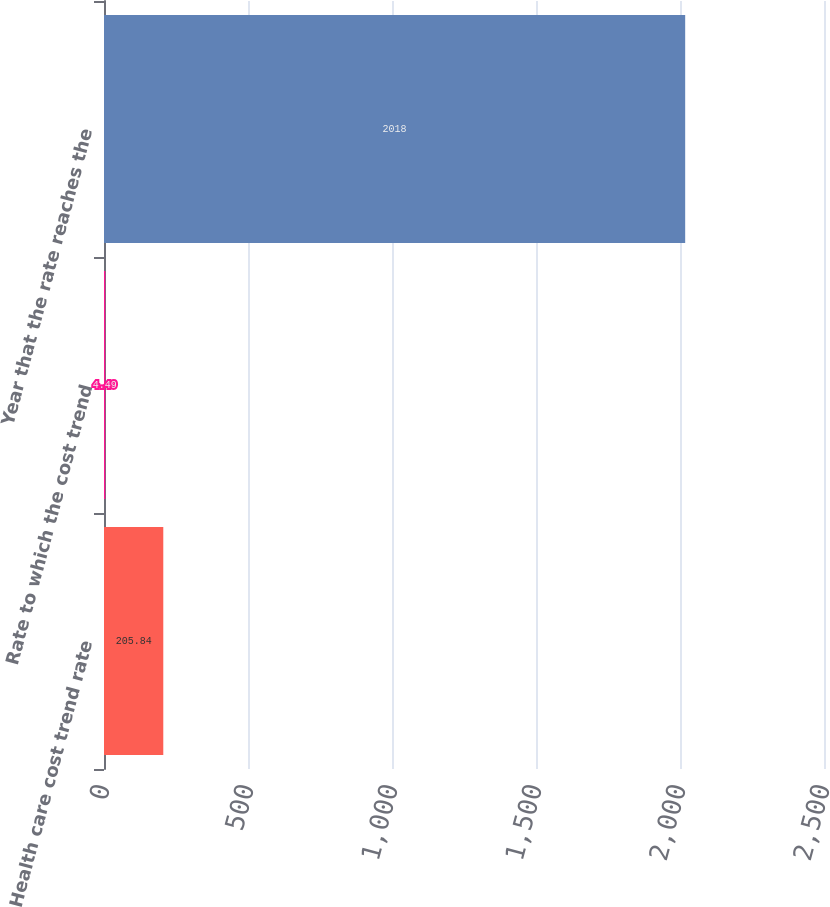Convert chart to OTSL. <chart><loc_0><loc_0><loc_500><loc_500><bar_chart><fcel>Health care cost trend rate<fcel>Rate to which the cost trend<fcel>Year that the rate reaches the<nl><fcel>205.84<fcel>4.49<fcel>2018<nl></chart> 